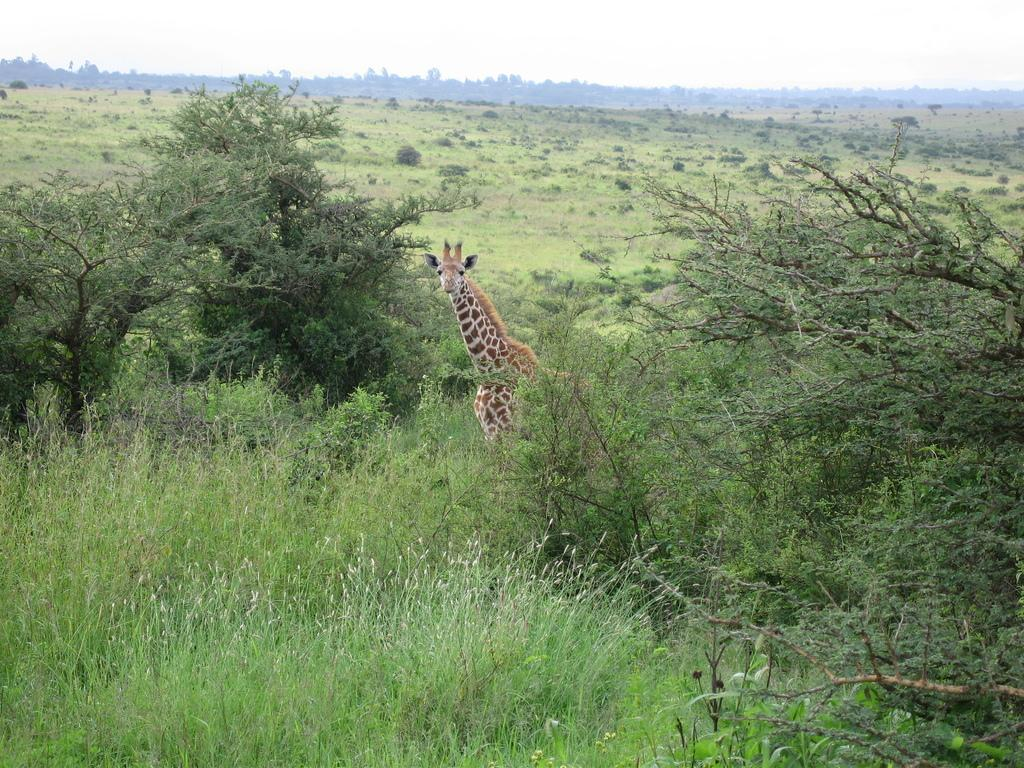What type of vegetation is in the foreground of the image? There is grass in the foreground of the image. What animal can be seen in the image? There is a giraffe in the image. Where are trees located on the left side of the image? There are trees on the left side of the image. Are there trees on both sides of the image? Yes, there are trees on both the left and right sides of the image. What can be seen in the background of the image? There are trees visible in the background of the image. What type of flowers can be seen in the image? There are no flowers mentioned or visible in the image. Can you describe the mother giraffe and her baby in the image? There is no mention of a mother giraffe or her baby in the image; only one giraffe is present. 